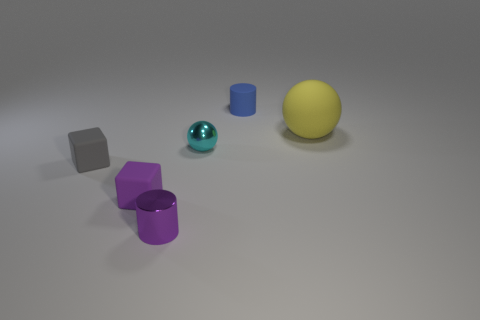Add 2 gray objects. How many objects exist? 8 Subtract all blue cylinders. How many cylinders are left? 1 Subtract 1 purple cubes. How many objects are left? 5 Subtract all spheres. How many objects are left? 4 Subtract 2 spheres. How many spheres are left? 0 Subtract all green cylinders. Subtract all yellow spheres. How many cylinders are left? 2 Subtract all green cylinders. How many blue balls are left? 0 Subtract all rubber cubes. Subtract all blue cylinders. How many objects are left? 3 Add 5 yellow matte balls. How many yellow matte balls are left? 6 Add 1 big brown objects. How many big brown objects exist? 1 